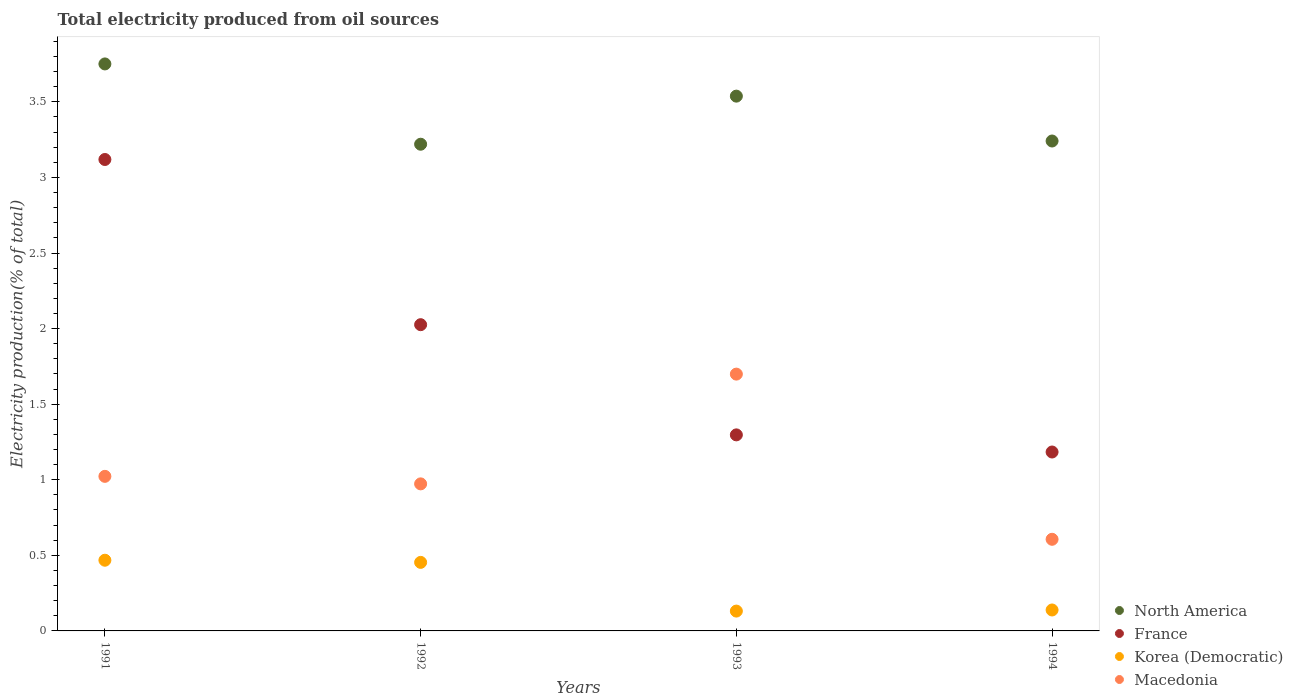Is the number of dotlines equal to the number of legend labels?
Your answer should be compact. Yes. What is the total electricity produced in North America in 1991?
Your response must be concise. 3.75. Across all years, what is the maximum total electricity produced in France?
Keep it short and to the point. 3.12. Across all years, what is the minimum total electricity produced in Korea (Democratic)?
Offer a very short reply. 0.13. What is the total total electricity produced in North America in the graph?
Offer a very short reply. 13.75. What is the difference between the total electricity produced in North America in 1992 and that in 1994?
Keep it short and to the point. -0.02. What is the difference between the total electricity produced in Korea (Democratic) in 1991 and the total electricity produced in North America in 1992?
Your answer should be very brief. -2.75. What is the average total electricity produced in Macedonia per year?
Your response must be concise. 1.08. In the year 1991, what is the difference between the total electricity produced in Korea (Democratic) and total electricity produced in Macedonia?
Your answer should be very brief. -0.55. In how many years, is the total electricity produced in France greater than 0.7 %?
Make the answer very short. 4. What is the ratio of the total electricity produced in Macedonia in 1991 to that in 1992?
Offer a terse response. 1.05. What is the difference between the highest and the second highest total electricity produced in Korea (Democratic)?
Your answer should be very brief. 0.01. What is the difference between the highest and the lowest total electricity produced in France?
Your answer should be compact. 1.94. Does the total electricity produced in North America monotonically increase over the years?
Give a very brief answer. No. Is the total electricity produced in France strictly greater than the total electricity produced in Macedonia over the years?
Make the answer very short. No. How many dotlines are there?
Make the answer very short. 4. How many years are there in the graph?
Offer a very short reply. 4. Are the values on the major ticks of Y-axis written in scientific E-notation?
Provide a short and direct response. No. What is the title of the graph?
Make the answer very short. Total electricity produced from oil sources. What is the label or title of the X-axis?
Ensure brevity in your answer.  Years. What is the label or title of the Y-axis?
Make the answer very short. Electricity production(% of total). What is the Electricity production(% of total) in North America in 1991?
Give a very brief answer. 3.75. What is the Electricity production(% of total) of France in 1991?
Offer a terse response. 3.12. What is the Electricity production(% of total) in Korea (Democratic) in 1991?
Provide a short and direct response. 0.47. What is the Electricity production(% of total) in Macedonia in 1991?
Offer a terse response. 1.02. What is the Electricity production(% of total) in North America in 1992?
Your answer should be compact. 3.22. What is the Electricity production(% of total) of France in 1992?
Provide a short and direct response. 2.03. What is the Electricity production(% of total) in Korea (Democratic) in 1992?
Offer a terse response. 0.45. What is the Electricity production(% of total) in Macedonia in 1992?
Offer a terse response. 0.97. What is the Electricity production(% of total) in North America in 1993?
Your answer should be very brief. 3.54. What is the Electricity production(% of total) in France in 1993?
Provide a succinct answer. 1.3. What is the Electricity production(% of total) in Korea (Democratic) in 1993?
Offer a terse response. 0.13. What is the Electricity production(% of total) in Macedonia in 1993?
Make the answer very short. 1.7. What is the Electricity production(% of total) of North America in 1994?
Your answer should be very brief. 3.24. What is the Electricity production(% of total) in France in 1994?
Offer a very short reply. 1.18. What is the Electricity production(% of total) in Korea (Democratic) in 1994?
Provide a succinct answer. 0.14. What is the Electricity production(% of total) of Macedonia in 1994?
Give a very brief answer. 0.61. Across all years, what is the maximum Electricity production(% of total) in North America?
Keep it short and to the point. 3.75. Across all years, what is the maximum Electricity production(% of total) of France?
Make the answer very short. 3.12. Across all years, what is the maximum Electricity production(% of total) of Korea (Democratic)?
Make the answer very short. 0.47. Across all years, what is the maximum Electricity production(% of total) in Macedonia?
Ensure brevity in your answer.  1.7. Across all years, what is the minimum Electricity production(% of total) in North America?
Give a very brief answer. 3.22. Across all years, what is the minimum Electricity production(% of total) of France?
Ensure brevity in your answer.  1.18. Across all years, what is the minimum Electricity production(% of total) of Korea (Democratic)?
Your answer should be compact. 0.13. Across all years, what is the minimum Electricity production(% of total) of Macedonia?
Offer a terse response. 0.61. What is the total Electricity production(% of total) of North America in the graph?
Your response must be concise. 13.75. What is the total Electricity production(% of total) in France in the graph?
Your answer should be very brief. 7.62. What is the total Electricity production(% of total) of Korea (Democratic) in the graph?
Make the answer very short. 1.19. What is the total Electricity production(% of total) in Macedonia in the graph?
Give a very brief answer. 4.3. What is the difference between the Electricity production(% of total) in North America in 1991 and that in 1992?
Your answer should be very brief. 0.53. What is the difference between the Electricity production(% of total) of France in 1991 and that in 1992?
Your response must be concise. 1.09. What is the difference between the Electricity production(% of total) of Korea (Democratic) in 1991 and that in 1992?
Keep it short and to the point. 0.01. What is the difference between the Electricity production(% of total) in Macedonia in 1991 and that in 1992?
Provide a short and direct response. 0.05. What is the difference between the Electricity production(% of total) in North America in 1991 and that in 1993?
Provide a short and direct response. 0.21. What is the difference between the Electricity production(% of total) of France in 1991 and that in 1993?
Your answer should be very brief. 1.82. What is the difference between the Electricity production(% of total) in Korea (Democratic) in 1991 and that in 1993?
Make the answer very short. 0.34. What is the difference between the Electricity production(% of total) of Macedonia in 1991 and that in 1993?
Make the answer very short. -0.68. What is the difference between the Electricity production(% of total) in North America in 1991 and that in 1994?
Keep it short and to the point. 0.51. What is the difference between the Electricity production(% of total) of France in 1991 and that in 1994?
Provide a succinct answer. 1.94. What is the difference between the Electricity production(% of total) in Korea (Democratic) in 1991 and that in 1994?
Your answer should be compact. 0.33. What is the difference between the Electricity production(% of total) of Macedonia in 1991 and that in 1994?
Keep it short and to the point. 0.42. What is the difference between the Electricity production(% of total) in North America in 1992 and that in 1993?
Make the answer very short. -0.32. What is the difference between the Electricity production(% of total) of France in 1992 and that in 1993?
Offer a terse response. 0.73. What is the difference between the Electricity production(% of total) of Korea (Democratic) in 1992 and that in 1993?
Your answer should be compact. 0.32. What is the difference between the Electricity production(% of total) in Macedonia in 1992 and that in 1993?
Your answer should be very brief. -0.73. What is the difference between the Electricity production(% of total) in North America in 1992 and that in 1994?
Offer a very short reply. -0.02. What is the difference between the Electricity production(% of total) of France in 1992 and that in 1994?
Give a very brief answer. 0.84. What is the difference between the Electricity production(% of total) of Korea (Democratic) in 1992 and that in 1994?
Your answer should be compact. 0.31. What is the difference between the Electricity production(% of total) of Macedonia in 1992 and that in 1994?
Ensure brevity in your answer.  0.37. What is the difference between the Electricity production(% of total) of North America in 1993 and that in 1994?
Offer a very short reply. 0.3. What is the difference between the Electricity production(% of total) in France in 1993 and that in 1994?
Your response must be concise. 0.11. What is the difference between the Electricity production(% of total) of Korea (Democratic) in 1993 and that in 1994?
Give a very brief answer. -0.01. What is the difference between the Electricity production(% of total) of Macedonia in 1993 and that in 1994?
Make the answer very short. 1.09. What is the difference between the Electricity production(% of total) of North America in 1991 and the Electricity production(% of total) of France in 1992?
Your answer should be very brief. 1.73. What is the difference between the Electricity production(% of total) of North America in 1991 and the Electricity production(% of total) of Korea (Democratic) in 1992?
Make the answer very short. 3.3. What is the difference between the Electricity production(% of total) in North America in 1991 and the Electricity production(% of total) in Macedonia in 1992?
Your response must be concise. 2.78. What is the difference between the Electricity production(% of total) in France in 1991 and the Electricity production(% of total) in Korea (Democratic) in 1992?
Offer a very short reply. 2.67. What is the difference between the Electricity production(% of total) in France in 1991 and the Electricity production(% of total) in Macedonia in 1992?
Provide a succinct answer. 2.15. What is the difference between the Electricity production(% of total) in Korea (Democratic) in 1991 and the Electricity production(% of total) in Macedonia in 1992?
Ensure brevity in your answer.  -0.51. What is the difference between the Electricity production(% of total) of North America in 1991 and the Electricity production(% of total) of France in 1993?
Give a very brief answer. 2.45. What is the difference between the Electricity production(% of total) in North America in 1991 and the Electricity production(% of total) in Korea (Democratic) in 1993?
Your response must be concise. 3.62. What is the difference between the Electricity production(% of total) in North America in 1991 and the Electricity production(% of total) in Macedonia in 1993?
Provide a short and direct response. 2.05. What is the difference between the Electricity production(% of total) in France in 1991 and the Electricity production(% of total) in Korea (Democratic) in 1993?
Offer a terse response. 2.99. What is the difference between the Electricity production(% of total) in France in 1991 and the Electricity production(% of total) in Macedonia in 1993?
Offer a very short reply. 1.42. What is the difference between the Electricity production(% of total) of Korea (Democratic) in 1991 and the Electricity production(% of total) of Macedonia in 1993?
Give a very brief answer. -1.23. What is the difference between the Electricity production(% of total) in North America in 1991 and the Electricity production(% of total) in France in 1994?
Ensure brevity in your answer.  2.57. What is the difference between the Electricity production(% of total) in North America in 1991 and the Electricity production(% of total) in Korea (Democratic) in 1994?
Give a very brief answer. 3.61. What is the difference between the Electricity production(% of total) in North America in 1991 and the Electricity production(% of total) in Macedonia in 1994?
Offer a terse response. 3.14. What is the difference between the Electricity production(% of total) in France in 1991 and the Electricity production(% of total) in Korea (Democratic) in 1994?
Ensure brevity in your answer.  2.98. What is the difference between the Electricity production(% of total) of France in 1991 and the Electricity production(% of total) of Macedonia in 1994?
Provide a short and direct response. 2.51. What is the difference between the Electricity production(% of total) of Korea (Democratic) in 1991 and the Electricity production(% of total) of Macedonia in 1994?
Provide a short and direct response. -0.14. What is the difference between the Electricity production(% of total) of North America in 1992 and the Electricity production(% of total) of France in 1993?
Your answer should be very brief. 1.92. What is the difference between the Electricity production(% of total) in North America in 1992 and the Electricity production(% of total) in Korea (Democratic) in 1993?
Provide a short and direct response. 3.09. What is the difference between the Electricity production(% of total) in North America in 1992 and the Electricity production(% of total) in Macedonia in 1993?
Offer a terse response. 1.52. What is the difference between the Electricity production(% of total) in France in 1992 and the Electricity production(% of total) in Korea (Democratic) in 1993?
Give a very brief answer. 1.89. What is the difference between the Electricity production(% of total) in France in 1992 and the Electricity production(% of total) in Macedonia in 1993?
Make the answer very short. 0.33. What is the difference between the Electricity production(% of total) of Korea (Democratic) in 1992 and the Electricity production(% of total) of Macedonia in 1993?
Make the answer very short. -1.25. What is the difference between the Electricity production(% of total) in North America in 1992 and the Electricity production(% of total) in France in 1994?
Keep it short and to the point. 2.04. What is the difference between the Electricity production(% of total) of North America in 1992 and the Electricity production(% of total) of Korea (Democratic) in 1994?
Keep it short and to the point. 3.08. What is the difference between the Electricity production(% of total) of North America in 1992 and the Electricity production(% of total) of Macedonia in 1994?
Your response must be concise. 2.61. What is the difference between the Electricity production(% of total) of France in 1992 and the Electricity production(% of total) of Korea (Democratic) in 1994?
Your answer should be very brief. 1.89. What is the difference between the Electricity production(% of total) in France in 1992 and the Electricity production(% of total) in Macedonia in 1994?
Your answer should be very brief. 1.42. What is the difference between the Electricity production(% of total) of Korea (Democratic) in 1992 and the Electricity production(% of total) of Macedonia in 1994?
Make the answer very short. -0.15. What is the difference between the Electricity production(% of total) in North America in 1993 and the Electricity production(% of total) in France in 1994?
Your response must be concise. 2.35. What is the difference between the Electricity production(% of total) of North America in 1993 and the Electricity production(% of total) of Korea (Democratic) in 1994?
Provide a succinct answer. 3.4. What is the difference between the Electricity production(% of total) of North America in 1993 and the Electricity production(% of total) of Macedonia in 1994?
Make the answer very short. 2.93. What is the difference between the Electricity production(% of total) in France in 1993 and the Electricity production(% of total) in Korea (Democratic) in 1994?
Offer a terse response. 1.16. What is the difference between the Electricity production(% of total) in France in 1993 and the Electricity production(% of total) in Macedonia in 1994?
Your answer should be very brief. 0.69. What is the difference between the Electricity production(% of total) in Korea (Democratic) in 1993 and the Electricity production(% of total) in Macedonia in 1994?
Keep it short and to the point. -0.47. What is the average Electricity production(% of total) in North America per year?
Provide a succinct answer. 3.44. What is the average Electricity production(% of total) of France per year?
Your response must be concise. 1.91. What is the average Electricity production(% of total) of Korea (Democratic) per year?
Provide a succinct answer. 0.3. What is the average Electricity production(% of total) in Macedonia per year?
Your answer should be very brief. 1.08. In the year 1991, what is the difference between the Electricity production(% of total) in North America and Electricity production(% of total) in France?
Give a very brief answer. 0.63. In the year 1991, what is the difference between the Electricity production(% of total) of North America and Electricity production(% of total) of Korea (Democratic)?
Provide a short and direct response. 3.28. In the year 1991, what is the difference between the Electricity production(% of total) of North America and Electricity production(% of total) of Macedonia?
Provide a succinct answer. 2.73. In the year 1991, what is the difference between the Electricity production(% of total) of France and Electricity production(% of total) of Korea (Democratic)?
Ensure brevity in your answer.  2.65. In the year 1991, what is the difference between the Electricity production(% of total) in France and Electricity production(% of total) in Macedonia?
Provide a succinct answer. 2.1. In the year 1991, what is the difference between the Electricity production(% of total) of Korea (Democratic) and Electricity production(% of total) of Macedonia?
Give a very brief answer. -0.55. In the year 1992, what is the difference between the Electricity production(% of total) of North America and Electricity production(% of total) of France?
Provide a short and direct response. 1.19. In the year 1992, what is the difference between the Electricity production(% of total) in North America and Electricity production(% of total) in Korea (Democratic)?
Make the answer very short. 2.77. In the year 1992, what is the difference between the Electricity production(% of total) in North America and Electricity production(% of total) in Macedonia?
Give a very brief answer. 2.25. In the year 1992, what is the difference between the Electricity production(% of total) in France and Electricity production(% of total) in Korea (Democratic)?
Offer a terse response. 1.57. In the year 1992, what is the difference between the Electricity production(% of total) in France and Electricity production(% of total) in Macedonia?
Give a very brief answer. 1.05. In the year 1992, what is the difference between the Electricity production(% of total) in Korea (Democratic) and Electricity production(% of total) in Macedonia?
Provide a short and direct response. -0.52. In the year 1993, what is the difference between the Electricity production(% of total) of North America and Electricity production(% of total) of France?
Provide a succinct answer. 2.24. In the year 1993, what is the difference between the Electricity production(% of total) of North America and Electricity production(% of total) of Korea (Democratic)?
Keep it short and to the point. 3.41. In the year 1993, what is the difference between the Electricity production(% of total) of North America and Electricity production(% of total) of Macedonia?
Your answer should be compact. 1.84. In the year 1993, what is the difference between the Electricity production(% of total) of France and Electricity production(% of total) of Korea (Democratic)?
Offer a very short reply. 1.17. In the year 1993, what is the difference between the Electricity production(% of total) of France and Electricity production(% of total) of Macedonia?
Give a very brief answer. -0.4. In the year 1993, what is the difference between the Electricity production(% of total) of Korea (Democratic) and Electricity production(% of total) of Macedonia?
Your response must be concise. -1.57. In the year 1994, what is the difference between the Electricity production(% of total) of North America and Electricity production(% of total) of France?
Give a very brief answer. 2.06. In the year 1994, what is the difference between the Electricity production(% of total) of North America and Electricity production(% of total) of Korea (Democratic)?
Ensure brevity in your answer.  3.1. In the year 1994, what is the difference between the Electricity production(% of total) of North America and Electricity production(% of total) of Macedonia?
Your answer should be compact. 2.63. In the year 1994, what is the difference between the Electricity production(% of total) in France and Electricity production(% of total) in Korea (Democratic)?
Make the answer very short. 1.04. In the year 1994, what is the difference between the Electricity production(% of total) in France and Electricity production(% of total) in Macedonia?
Give a very brief answer. 0.58. In the year 1994, what is the difference between the Electricity production(% of total) in Korea (Democratic) and Electricity production(% of total) in Macedonia?
Offer a terse response. -0.47. What is the ratio of the Electricity production(% of total) of North America in 1991 to that in 1992?
Offer a terse response. 1.17. What is the ratio of the Electricity production(% of total) of France in 1991 to that in 1992?
Ensure brevity in your answer.  1.54. What is the ratio of the Electricity production(% of total) of Korea (Democratic) in 1991 to that in 1992?
Ensure brevity in your answer.  1.03. What is the ratio of the Electricity production(% of total) in Macedonia in 1991 to that in 1992?
Your answer should be compact. 1.05. What is the ratio of the Electricity production(% of total) of North America in 1991 to that in 1993?
Give a very brief answer. 1.06. What is the ratio of the Electricity production(% of total) of France in 1991 to that in 1993?
Your response must be concise. 2.4. What is the ratio of the Electricity production(% of total) of Korea (Democratic) in 1991 to that in 1993?
Your answer should be compact. 3.56. What is the ratio of the Electricity production(% of total) in Macedonia in 1991 to that in 1993?
Your answer should be very brief. 0.6. What is the ratio of the Electricity production(% of total) of North America in 1991 to that in 1994?
Provide a succinct answer. 1.16. What is the ratio of the Electricity production(% of total) in France in 1991 to that in 1994?
Offer a very short reply. 2.63. What is the ratio of the Electricity production(% of total) of Korea (Democratic) in 1991 to that in 1994?
Ensure brevity in your answer.  3.38. What is the ratio of the Electricity production(% of total) in Macedonia in 1991 to that in 1994?
Offer a very short reply. 1.69. What is the ratio of the Electricity production(% of total) in North America in 1992 to that in 1993?
Provide a short and direct response. 0.91. What is the ratio of the Electricity production(% of total) in France in 1992 to that in 1993?
Ensure brevity in your answer.  1.56. What is the ratio of the Electricity production(% of total) in Korea (Democratic) in 1992 to that in 1993?
Offer a very short reply. 3.46. What is the ratio of the Electricity production(% of total) in Macedonia in 1992 to that in 1993?
Offer a very short reply. 0.57. What is the ratio of the Electricity production(% of total) in North America in 1992 to that in 1994?
Your answer should be compact. 0.99. What is the ratio of the Electricity production(% of total) in France in 1992 to that in 1994?
Provide a succinct answer. 1.71. What is the ratio of the Electricity production(% of total) of Korea (Democratic) in 1992 to that in 1994?
Offer a terse response. 3.27. What is the ratio of the Electricity production(% of total) of Macedonia in 1992 to that in 1994?
Ensure brevity in your answer.  1.6. What is the ratio of the Electricity production(% of total) in North America in 1993 to that in 1994?
Ensure brevity in your answer.  1.09. What is the ratio of the Electricity production(% of total) of France in 1993 to that in 1994?
Offer a terse response. 1.1. What is the ratio of the Electricity production(% of total) in Korea (Democratic) in 1993 to that in 1994?
Your response must be concise. 0.95. What is the ratio of the Electricity production(% of total) of Macedonia in 1993 to that in 1994?
Provide a short and direct response. 2.8. What is the difference between the highest and the second highest Electricity production(% of total) in North America?
Ensure brevity in your answer.  0.21. What is the difference between the highest and the second highest Electricity production(% of total) in France?
Keep it short and to the point. 1.09. What is the difference between the highest and the second highest Electricity production(% of total) of Korea (Democratic)?
Your response must be concise. 0.01. What is the difference between the highest and the second highest Electricity production(% of total) of Macedonia?
Ensure brevity in your answer.  0.68. What is the difference between the highest and the lowest Electricity production(% of total) of North America?
Make the answer very short. 0.53. What is the difference between the highest and the lowest Electricity production(% of total) of France?
Give a very brief answer. 1.94. What is the difference between the highest and the lowest Electricity production(% of total) in Korea (Democratic)?
Your answer should be compact. 0.34. What is the difference between the highest and the lowest Electricity production(% of total) of Macedonia?
Your response must be concise. 1.09. 